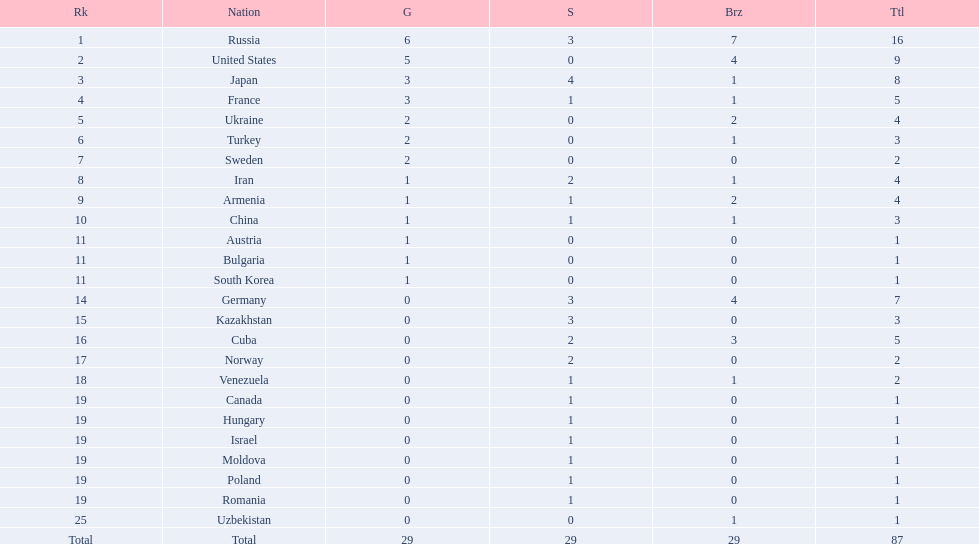What was iran's ranking? 8. What was germany's ranking? 14. Between iran and germany, which was not in the top 10? Germany. 